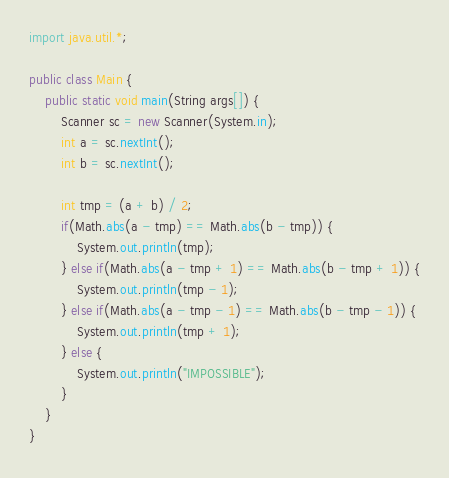<code> <loc_0><loc_0><loc_500><loc_500><_Java_>import java.util.*;

public class Main {
    public static void main(String args[]) {
        Scanner sc = new Scanner(System.in);
        int a = sc.nextInt();
        int b = sc.nextInt();

        int tmp = (a + b) / 2;
        if(Math.abs(a - tmp) == Math.abs(b - tmp)) {
            System.out.println(tmp);
        } else if(Math.abs(a - tmp + 1) == Math.abs(b - tmp + 1)) {
            System.out.println(tmp - 1);
        } else if(Math.abs(a - tmp - 1) == Math.abs(b - tmp - 1)) {
            System.out.println(tmp + 1);
        } else {
            System.out.println("IMPOSSIBLE");
        }
    } 
}</code> 